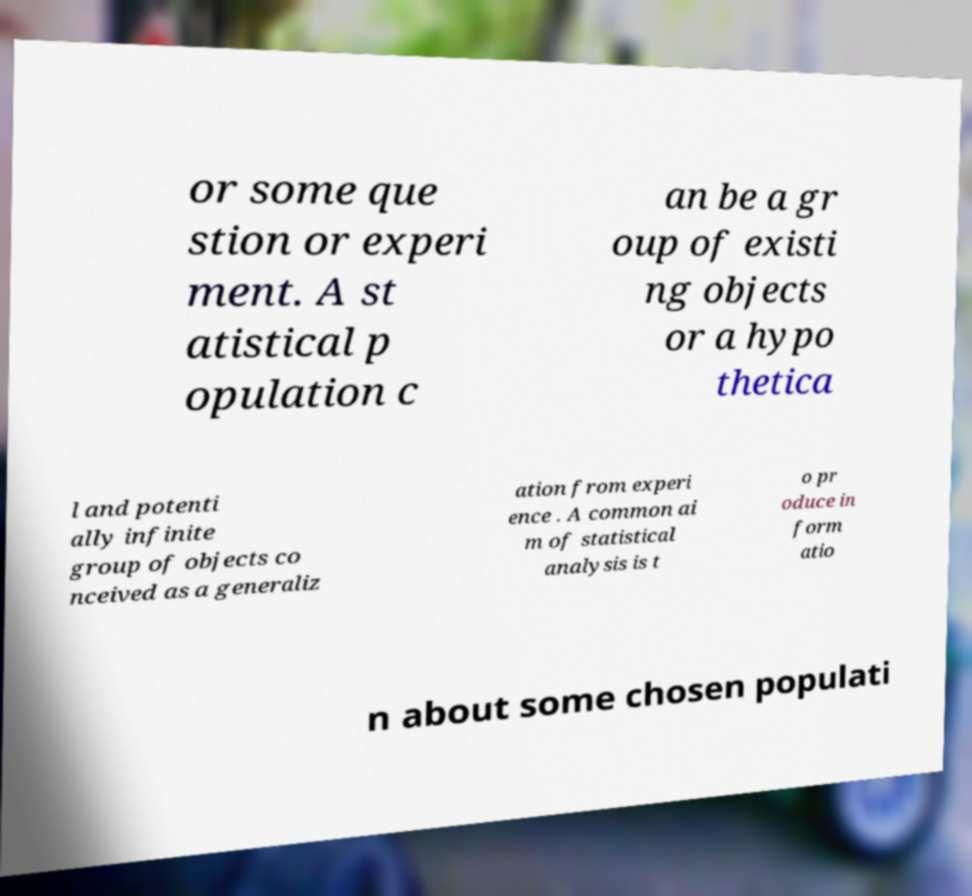Could you extract and type out the text from this image? or some que stion or experi ment. A st atistical p opulation c an be a gr oup of existi ng objects or a hypo thetica l and potenti ally infinite group of objects co nceived as a generaliz ation from experi ence . A common ai m of statistical analysis is t o pr oduce in form atio n about some chosen populati 